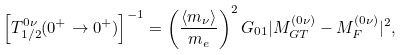<formula> <loc_0><loc_0><loc_500><loc_500>\left [ T _ { 1 / 2 } ^ { 0 \nu } ( 0 ^ { + } \to 0 ^ { + } ) \right ] ^ { - 1 } = \left ( \frac { \left \langle m _ { \nu } \right \rangle } { m _ { e } } \right ) ^ { 2 } G _ { 0 1 } | M ^ { \left ( 0 \nu \right ) } _ { G T } - M ^ { \left ( 0 \nu \right ) } _ { F } | ^ { 2 } ,</formula> 